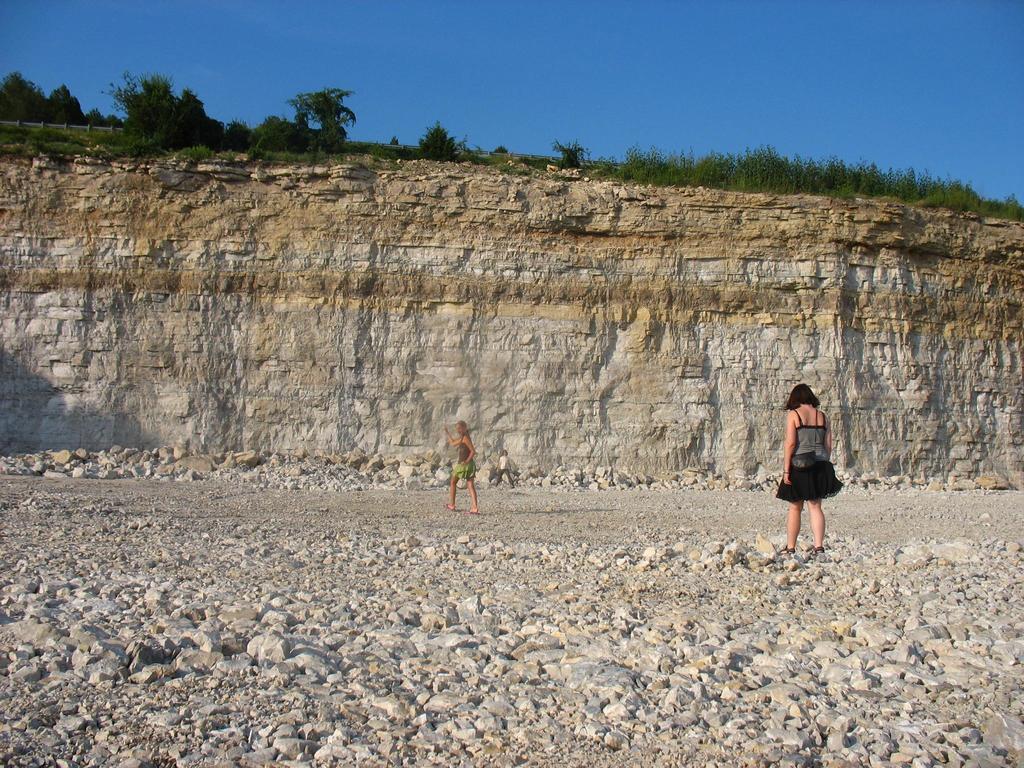How would you summarize this image in a sentence or two? This image consists of two women. On the right, the woman is wearing a black dress. At the bottom, there are rocks. In the front, there is a big rock along with grass and small plants. At the top, there is sky. 